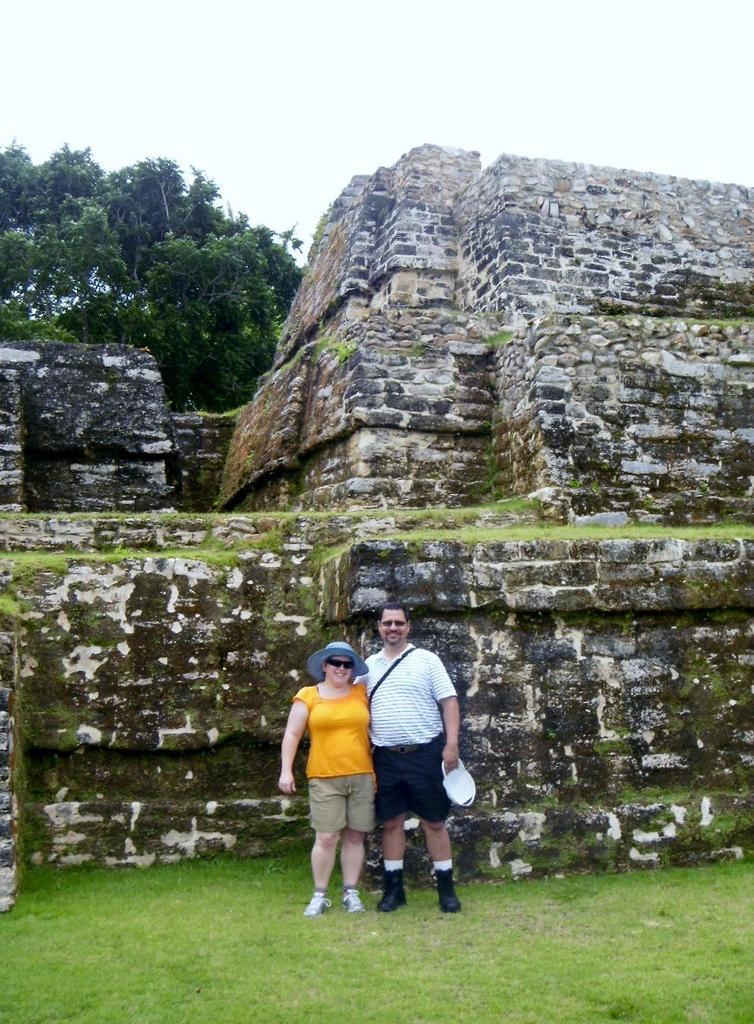In one or two sentences, can you explain what this image depicts? As we can see in the image there is grass, two people standing, wall, trees and sky. 